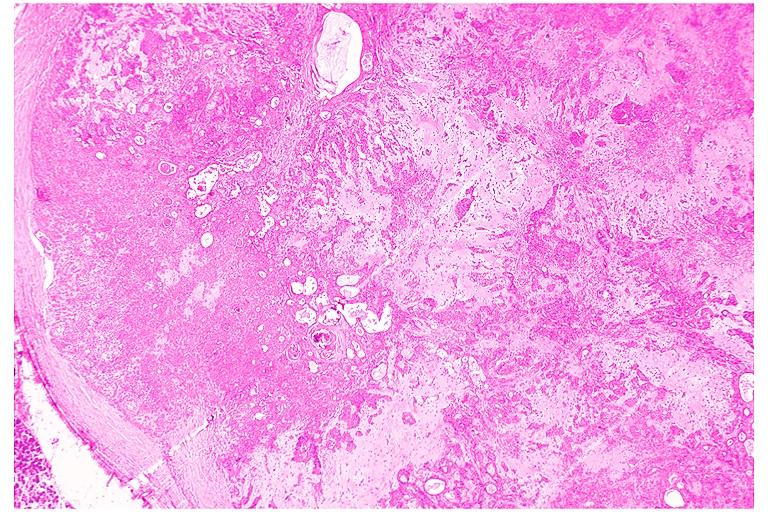does edema show pleomorphic adenoma benign mixed tumor?
Answer the question using a single word or phrase. No 